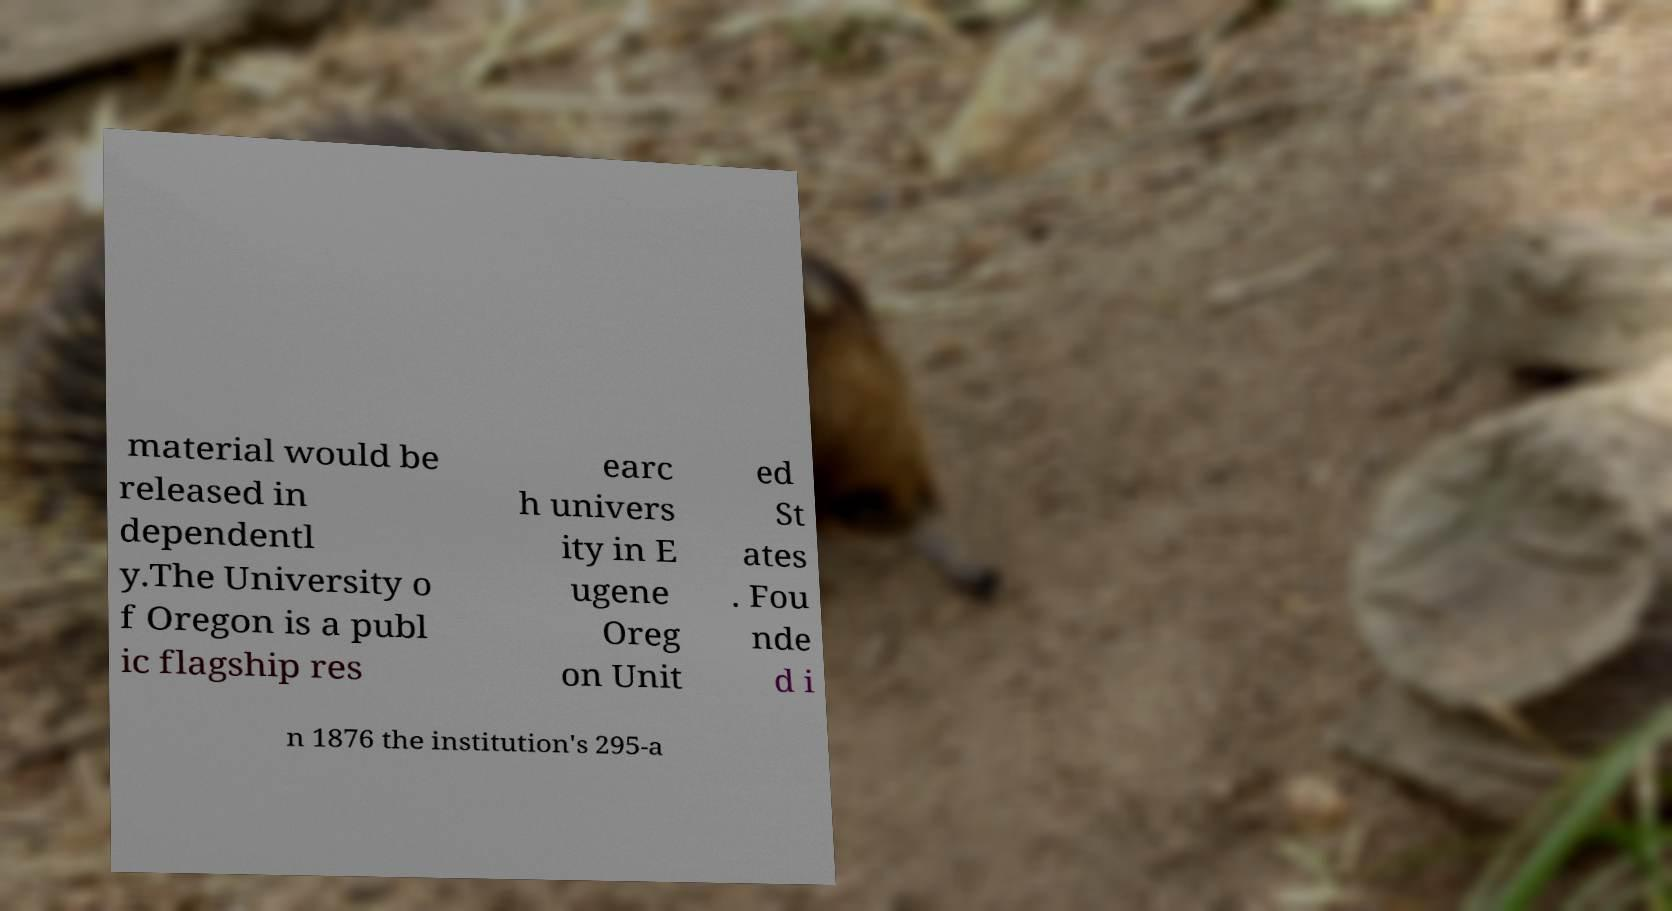For documentation purposes, I need the text within this image transcribed. Could you provide that? material would be released in dependentl y.The University o f Oregon is a publ ic flagship res earc h univers ity in E ugene Oreg on Unit ed St ates . Fou nde d i n 1876 the institution's 295-a 